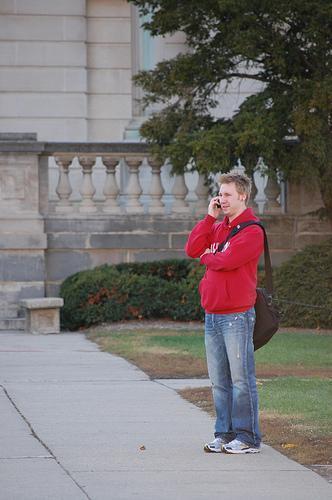How many people have luggage?
Give a very brief answer. 1. How many people on the sidewalk?
Give a very brief answer. 1. How many chairs can you see that are empty?
Give a very brief answer. 0. 